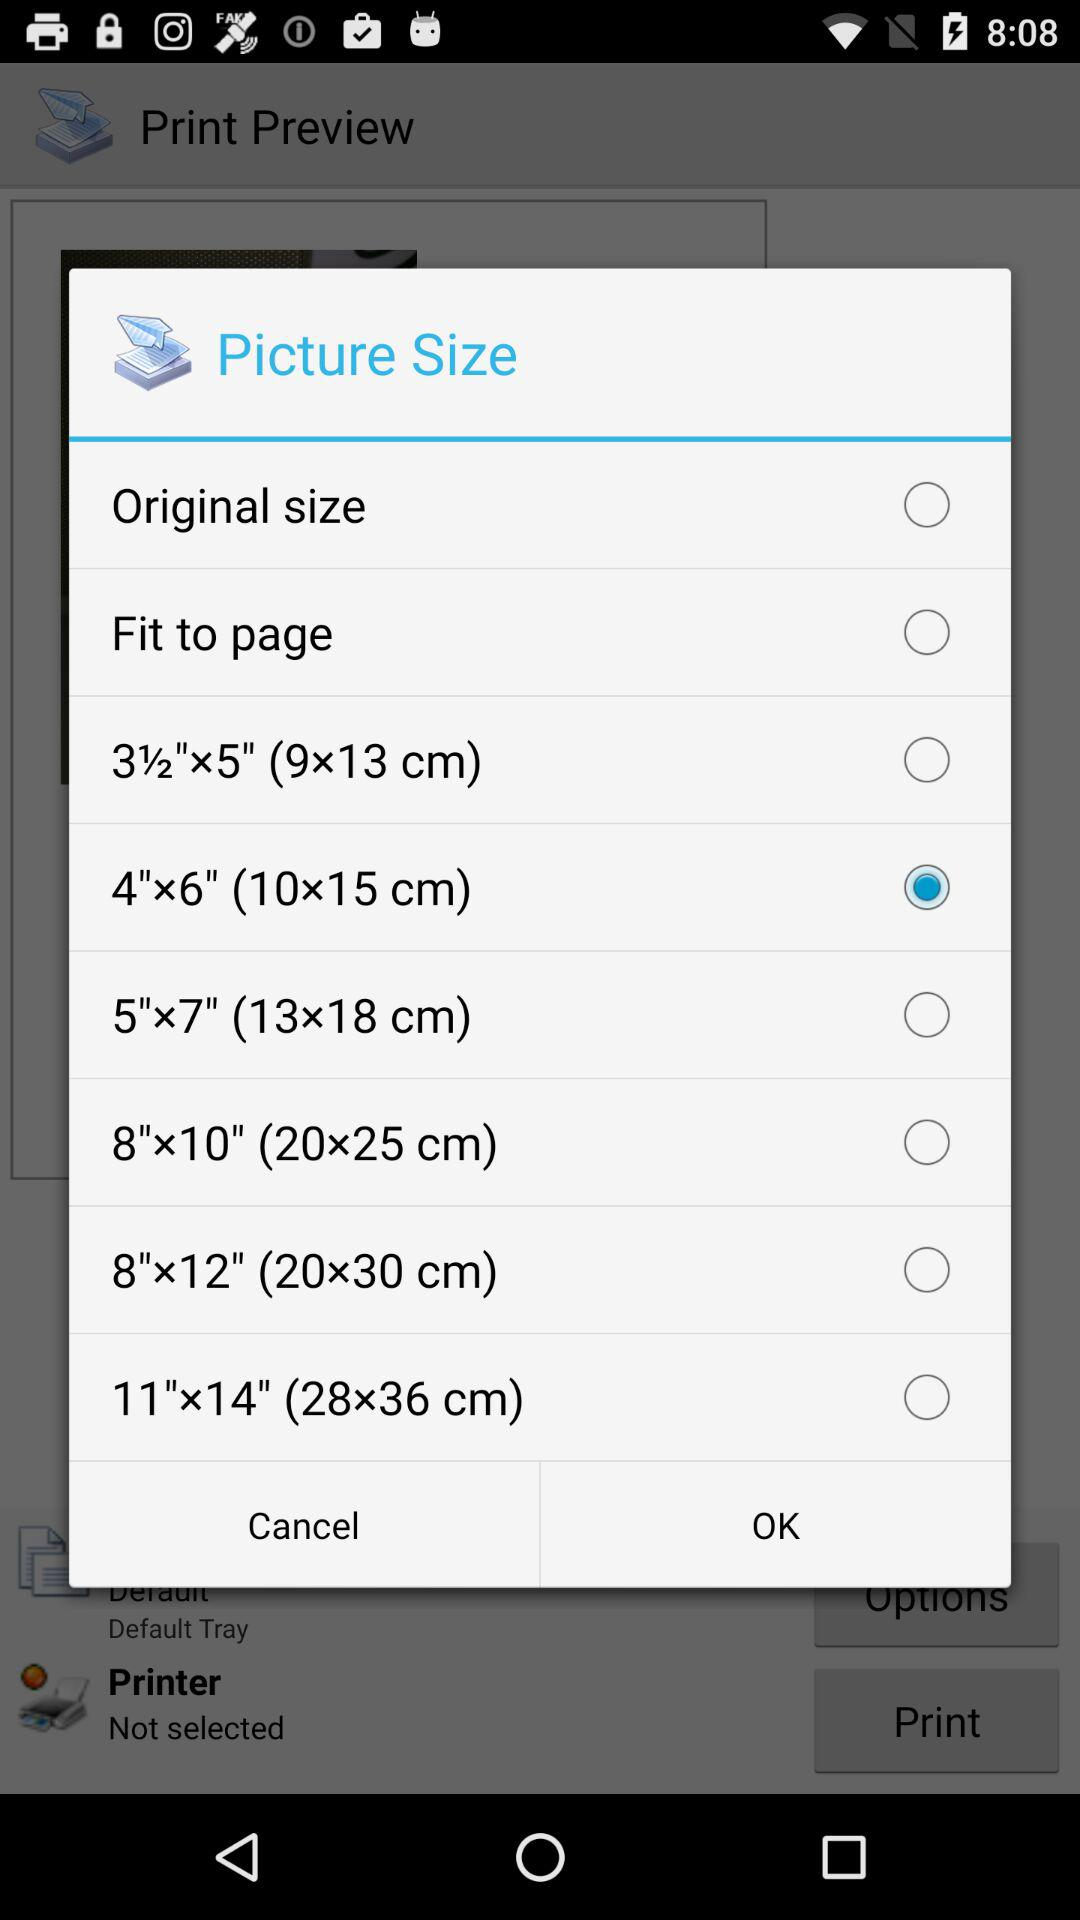How many picture size options are there?
Answer the question using a single word or phrase. 8 